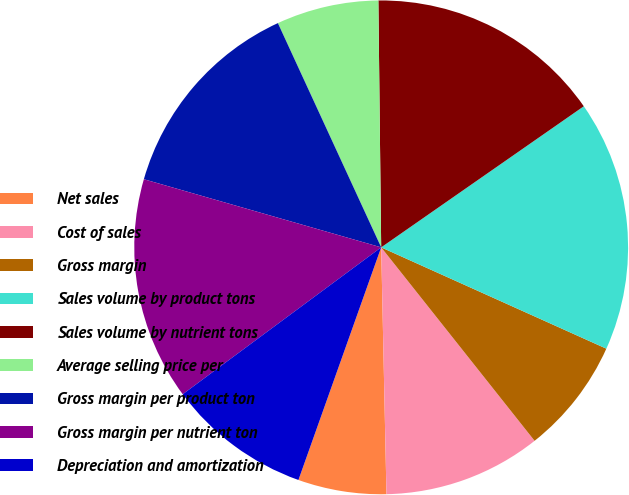Convert chart to OTSL. <chart><loc_0><loc_0><loc_500><loc_500><pie_chart><fcel>Net sales<fcel>Cost of sales<fcel>Gross margin<fcel>Sales volume by product tons<fcel>Sales volume by nutrient tons<fcel>Average selling price per<fcel>Gross margin per product ton<fcel>Gross margin per nutrient ton<fcel>Depreciation and amortization<nl><fcel>5.78%<fcel>10.33%<fcel>7.6%<fcel>16.41%<fcel>15.5%<fcel>6.69%<fcel>13.68%<fcel>14.59%<fcel>9.42%<nl></chart> 